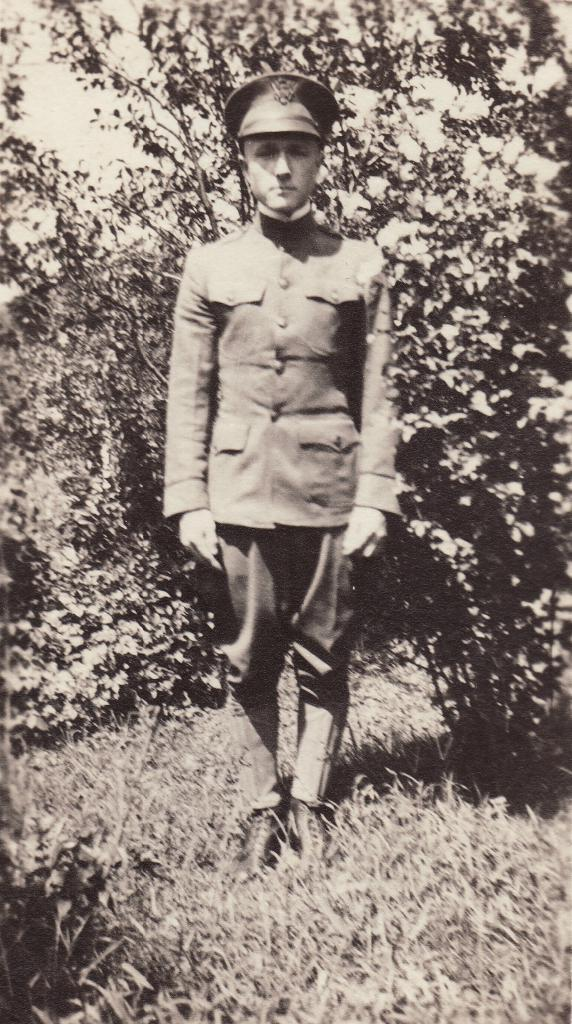Who is present in the image? There is a man in the picture. What type of clothing is the man wearing? The man is wearing a coat, a hat, and pants. What is the man standing on? The man is standing on the grass. What can be seen in the background of the image? There are plants in the background of the image. How many trains can be seen in the image? There are no trains present in the image. What type of change does the man have in his pocket in the image? There is no information about the man's pocket or any change in the image. 